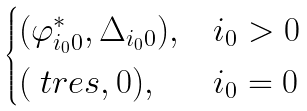<formula> <loc_0><loc_0><loc_500><loc_500>\begin{cases} ( \varphi _ { i _ { 0 } 0 } ^ { * } , \Delta _ { i _ { 0 } 0 } ) , & i _ { 0 } > 0 \\ ( \ t { r e s } , 0 ) , & i _ { 0 } = 0 \end{cases}</formula> 